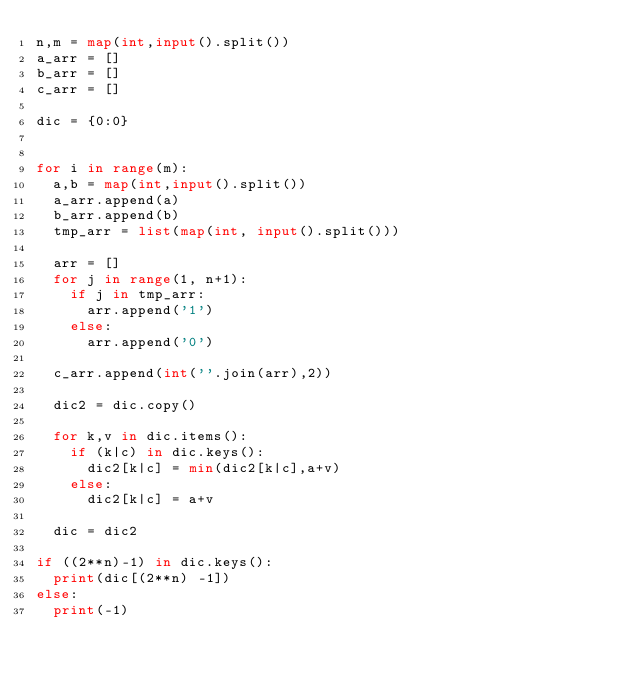Convert code to text. <code><loc_0><loc_0><loc_500><loc_500><_Python_>n,m = map(int,input().split())
a_arr = []
b_arr = []
c_arr = []
 
dic = {0:0}
 
 
for i in range(m):
  a,b = map(int,input().split())
  a_arr.append(a)
  b_arr.append(b)
  tmp_arr = list(map(int, input().split()))
  
  arr = []
  for j in range(1, n+1):
    if j in tmp_arr:
      arr.append('1')
    else:
      arr.append('0')
  
  c_arr.append(int(''.join(arr),2))
  
  dic2 = dic.copy()
  
  for k,v in dic.items():
    if (k|c) in dic.keys():
      dic2[k|c] = min(dic2[k|c],a+v)
    else:
      dic2[k|c] = a+v
 
  dic = dic2
 
if ((2**n)-1) in dic.keys():
  print(dic[(2**n) -1])
else:
  print(-1)</code> 